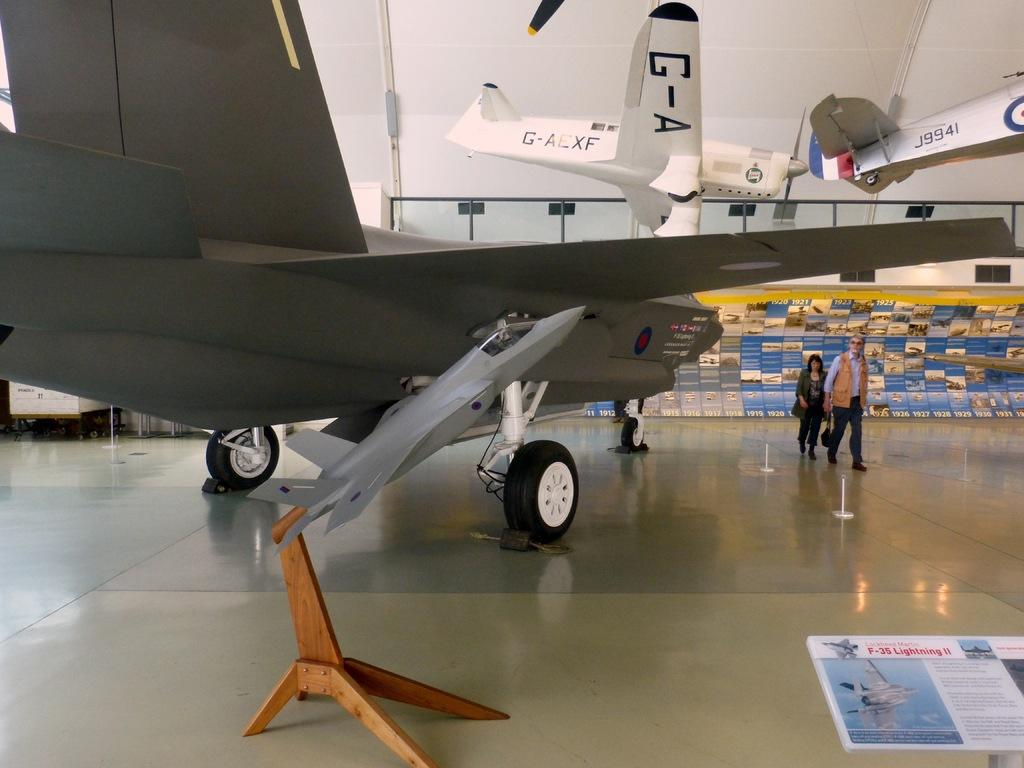Provide a one-sentence caption for the provided image. A man and a woman are walking through a museum that has an airplane with J9941 on it suspended from the ceiling. 